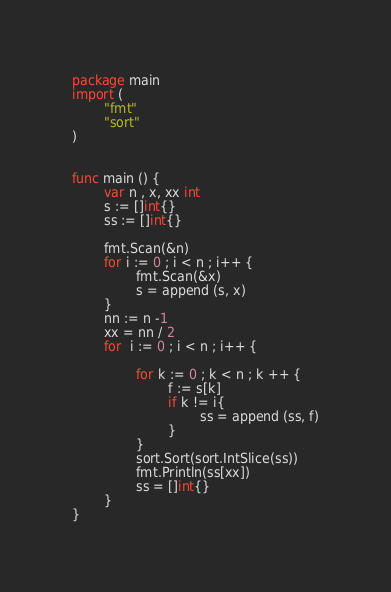<code> <loc_0><loc_0><loc_500><loc_500><_Go_>package main 
import (
        "fmt"
        "sort"
)


func main () {
        var n , x, xx int 
        s := []int{}
        ss := []int{}

        fmt.Scan(&n)
        for i := 0 ; i < n ; i++ {
                fmt.Scan(&x)
                s = append (s, x)
        }
        nn := n -1 
        xx = nn / 2 
        for  i := 0 ; i < n ; i++ {
                
                for k := 0 ; k < n ; k ++ {
                        f := s[k]
                        if k != i{
                                ss = append (ss, f)
                        }
                }
                sort.Sort(sort.IntSlice(ss))
                fmt.Println(ss[xx])
                ss = []int{}
        }
}
</code> 